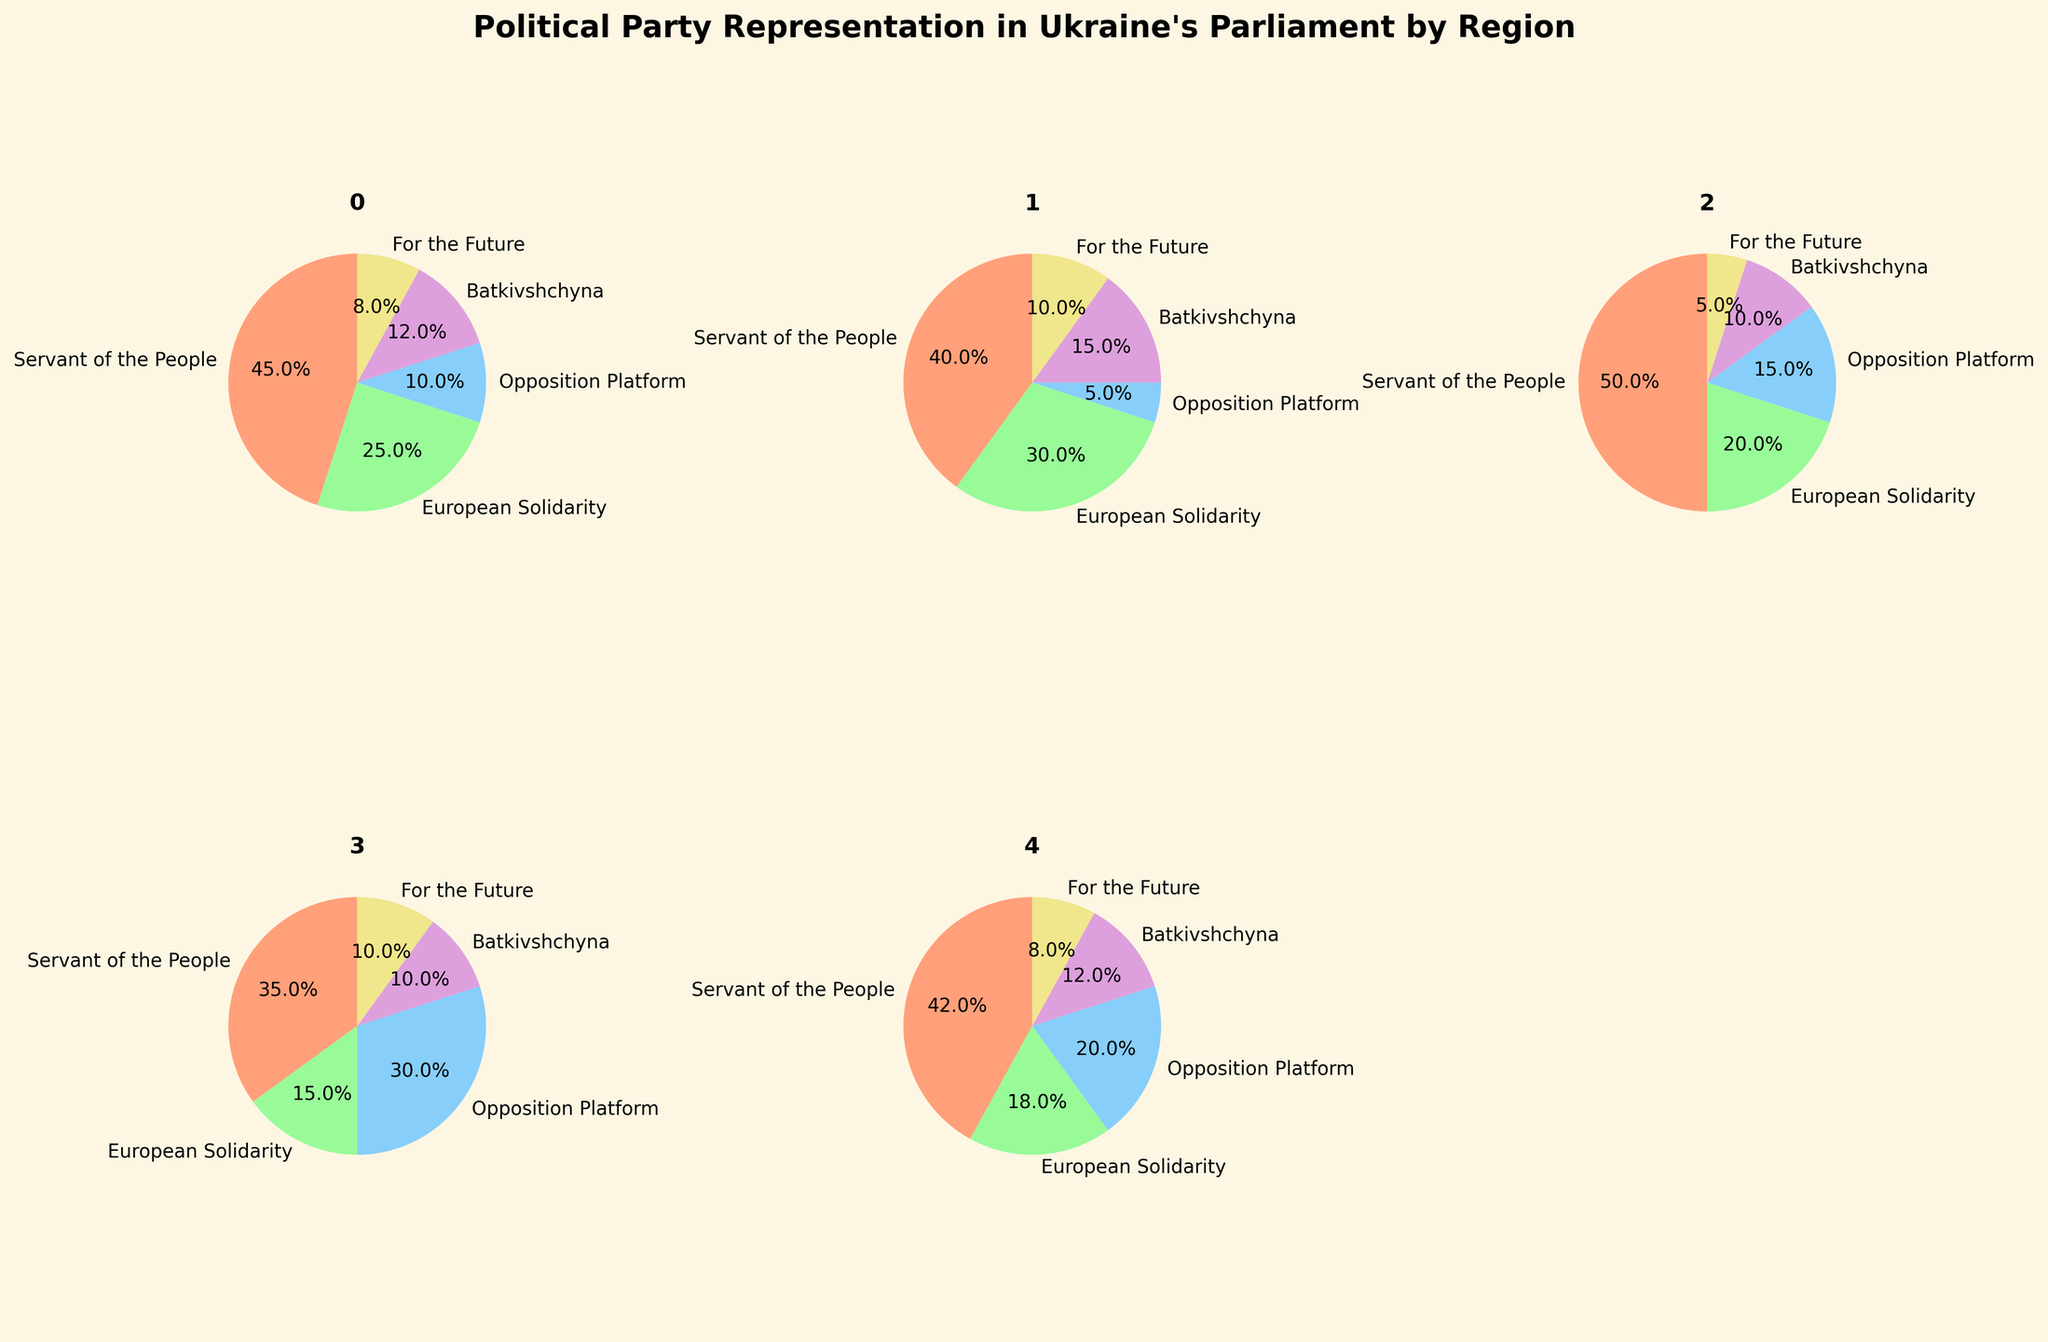What's the most represented political party in Kyiv? From the pie chart for Kyiv, observe the slice corresponding to each political party. The Servant of the People party has the largest slice.
Answer: Servant of the People What percentage of representation does the Opposition Platform have in Eastern Ukraine? Check the pie chart for Eastern Ukraine and locate the slice labeled Opposition Platform. The percentage is indicated on the chart.
Answer: 30% Which region has the highest percentage of European Solidarity representation? Compare the pie charts to see the percentage slices labeled European Solidarity for each region. Western Ukraine has the highest with 30%.
Answer: Western Ukraine How does the representation of For the Future in Southern Ukraine compare to that in Central Ukraine? Look at the slices for For the Future in the pie charts for Southern and Central Ukraine. Southern Ukraine has 8% and Central Ukraine has 5%.
Answer: Southern Ukraine has a higher representation What is the combined percentage of Batkivshchyna representation in all regions? Sum the percentages of Batkivshchyna for each region: Kyiv (12%) + Western Ukraine (15%) + Central Ukraine (10%) + Eastern Ukraine (10%) + Southern Ukraine (12%).
Answer: 59% How does the percentage of Opposition Platform in Central Ukraine compare to that in Kyiv? Central Ukraine has 15% and Kyiv has 10%. Calculate the difference.
Answer: Central Ukraine is 5% higher Which regions have more than 20% representation for Servant of the People? Servant of the People’s slices in Kyiv (45%), Western Ukraine (40%), Central Ukraine (50%), Eastern Ukraine (35%), Southern Ukraine (42%). All regions have more than 20%.
Answer: All Regions What combined percentage of Western Ukraine’s representation consists of Servant of the People and European Solidarity? Add the percentages of Servant of the People (40%) and European Solidarity (30%) in Western Ukraine.
Answer: 70% In which region is the representation of Batkivshchyna equal to that of For the Future? Compare the slices for Batkivshchyna and For the Future across all regions. Both are 10% in Eastern Ukraine.
Answer: Eastern Ukraine In which region does European Solidarity have a larger representation than Opposition Platform? Compare the slices for European Solidarity and Opposition Platform in each region. This is true for Kyiv, Western Ukraine, and Southern Ukraine.
Answer: Kyiv, Western Ukraine, and Southern Ukraine 